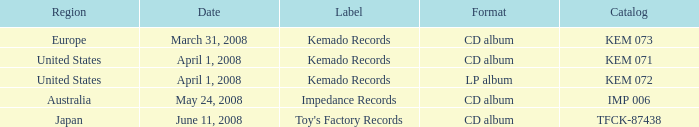Which Region has a Catalog of kem 072? United States. 